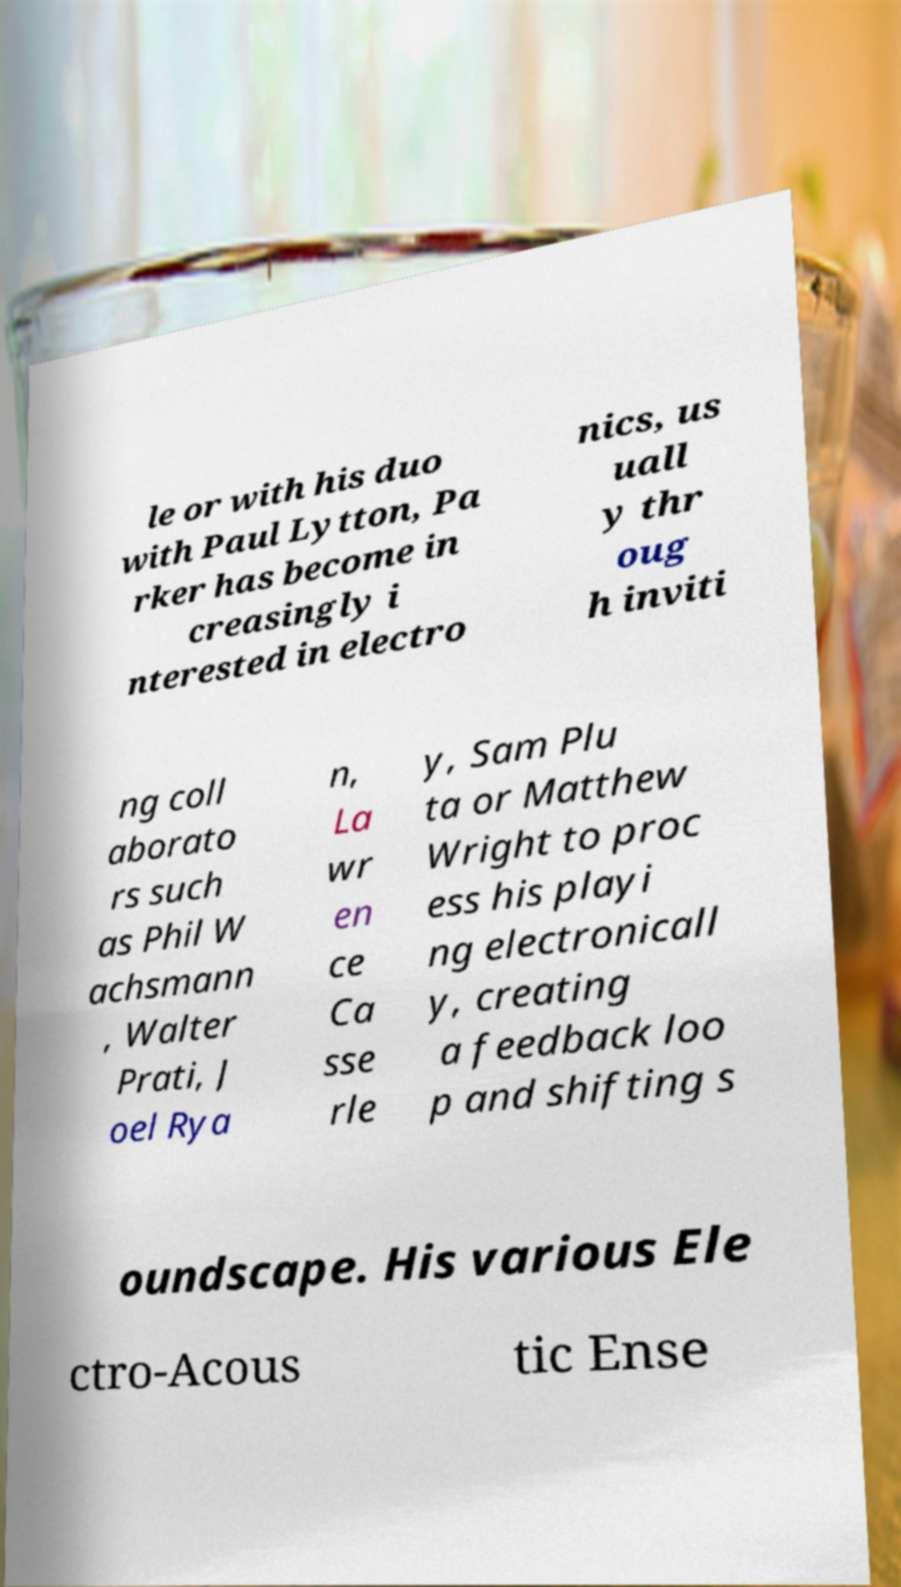I need the written content from this picture converted into text. Can you do that? le or with his duo with Paul Lytton, Pa rker has become in creasingly i nterested in electro nics, us uall y thr oug h inviti ng coll aborato rs such as Phil W achsmann , Walter Prati, J oel Rya n, La wr en ce Ca sse rle y, Sam Plu ta or Matthew Wright to proc ess his playi ng electronicall y, creating a feedback loo p and shifting s oundscape. His various Ele ctro-Acous tic Ense 